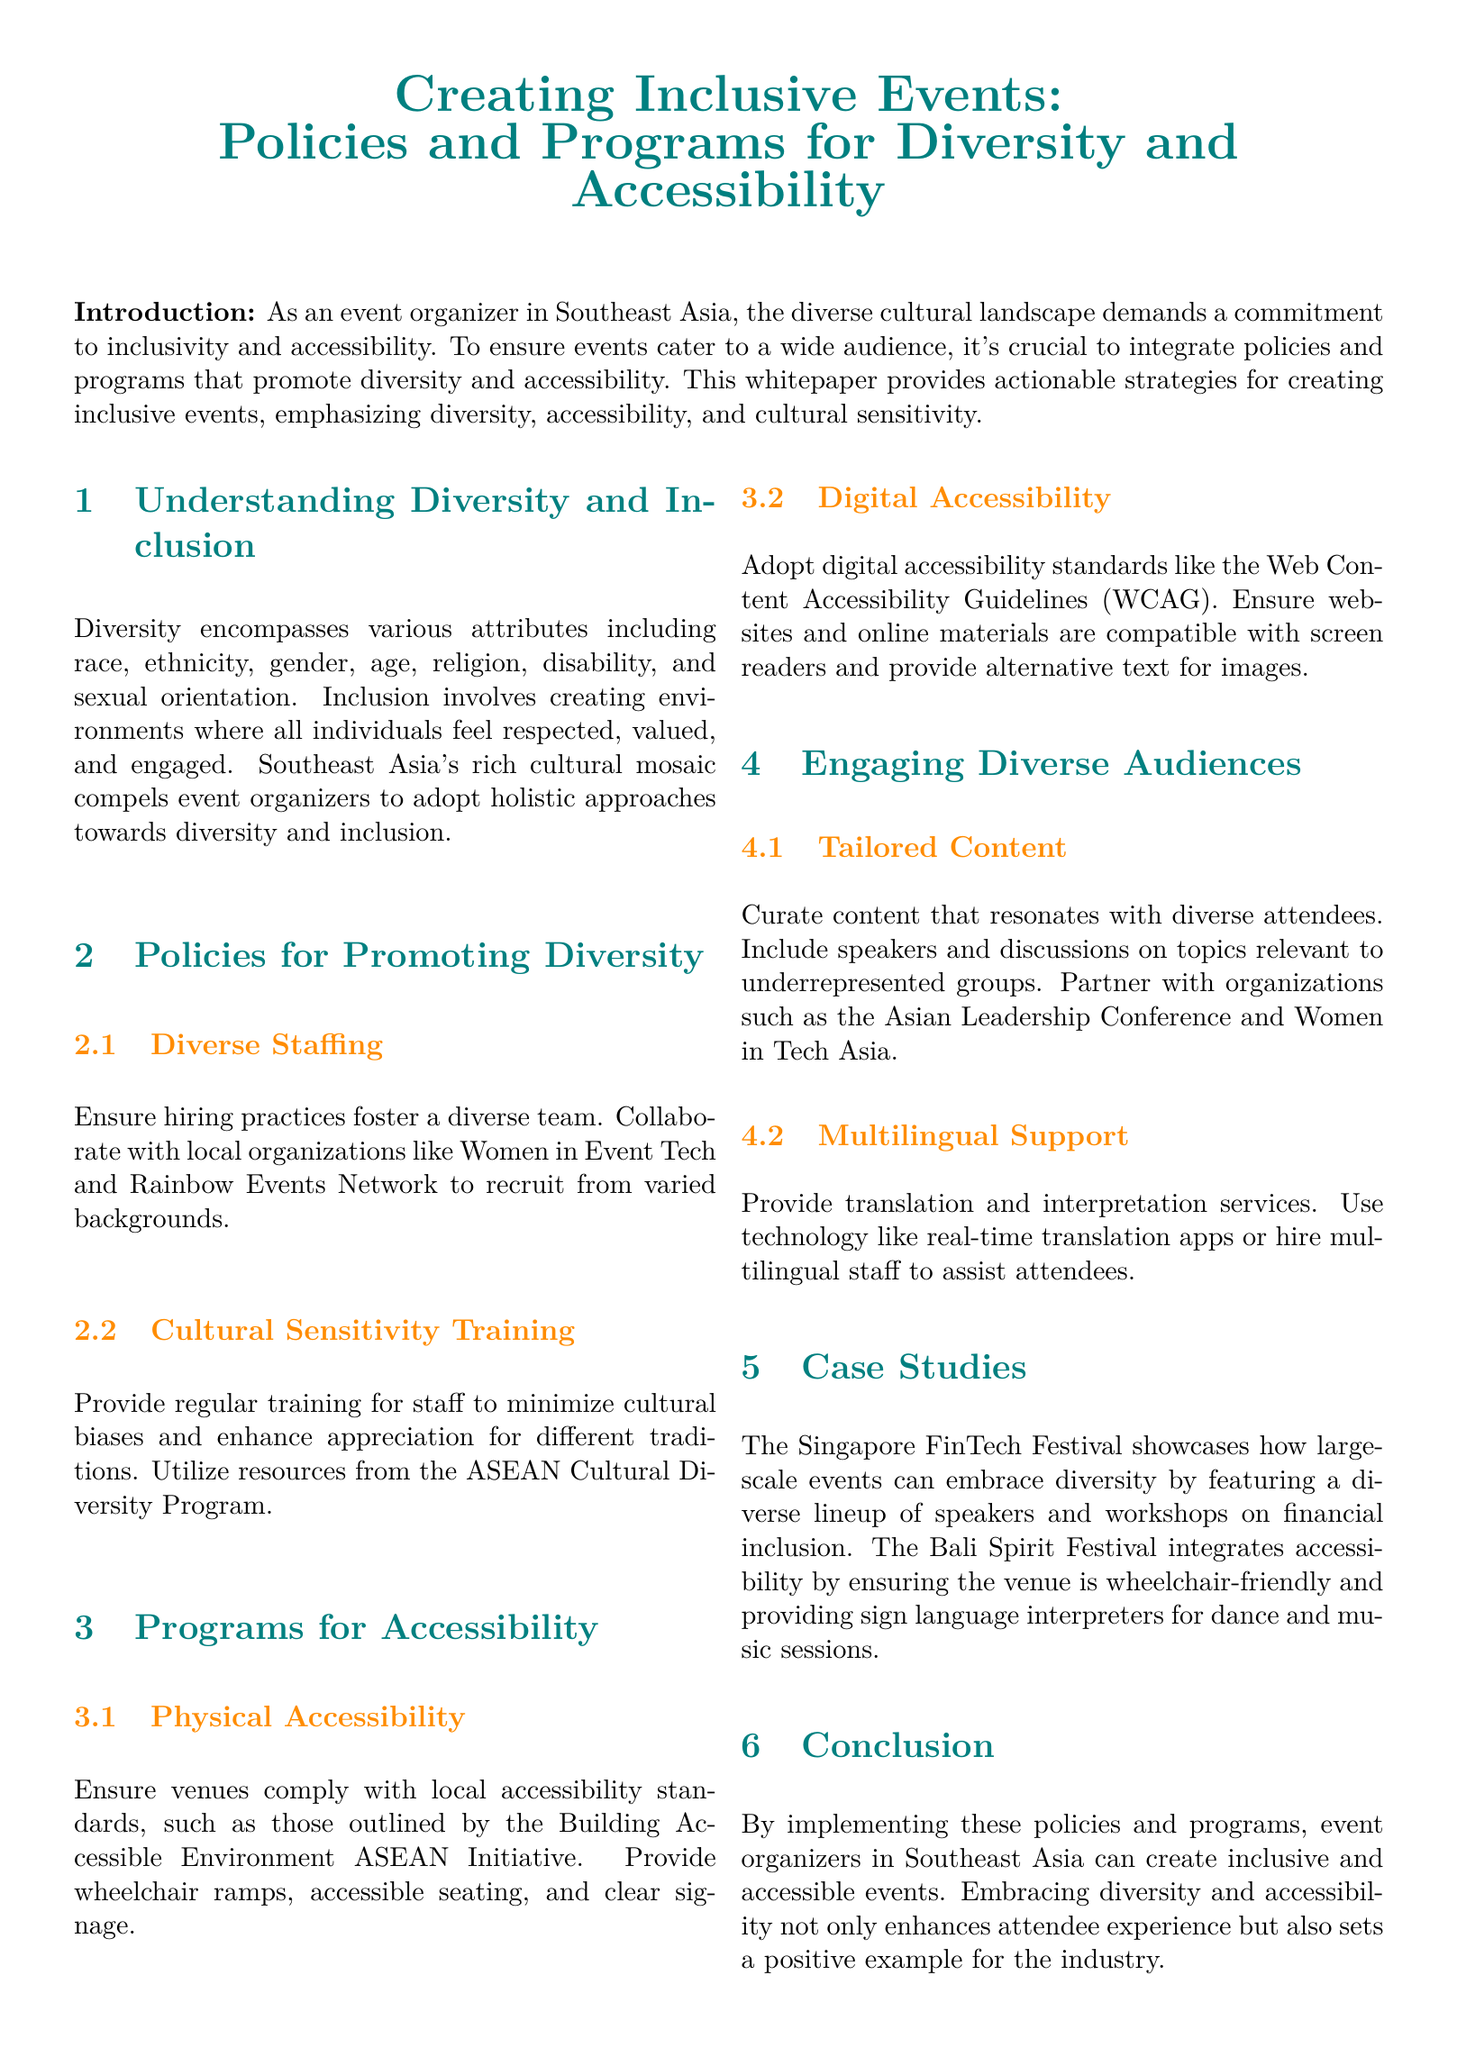What is the main focus of the whitepaper? The main focus is on creating inclusive events that promote diversity and accessibility.
Answer: Inclusive events What organization is mentioned for diverse staffing collaboration? The document mentions collaborating with Women in Event Tech.
Answer: Women in Event Tech What training is recommended for staff? The document recommends providing cultural sensitivity training.
Answer: Cultural sensitivity training What initiative ensures venues comply with accessibility standards? Venues should comply with the Building Accessible Environment ASEAN Initiative.
Answer: Building Accessible Environment ASEAN Initiative Which event is cited as a case study for diversity? The Singapore FinTech Festival is showcased as a case study for diversity.
Answer: Singapore FinTech Festival What technology is suggested for multilingual support? Real-time translation apps are suggested for multilingual support.
Answer: Real-time translation apps What is the purpose of the case studies section? The purpose is to showcase practical examples of inclusive and accessible events.
Answer: Showcase practical examples What email address is provided for contact information? The contact email provided is info@southeasiaevents.com.
Answer: info@southeasiaevents.com What does the whitepaper aim to enhance by adopting these policies and programs? The whitepaper aims to enhance the attendee experience.
Answer: Attendee experience 